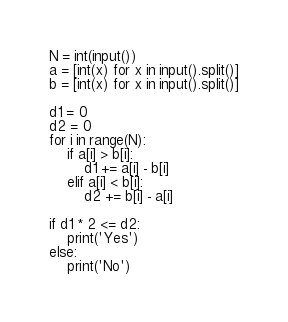Convert code to text. <code><loc_0><loc_0><loc_500><loc_500><_Python_>N = int(input())
a = [int(x) for x in input().split()]
b = [int(x) for x in input().split()]

d1 = 0
d2 = 0
for i in range(N):
    if a[i] > b[i]:
        d1 += a[i] - b[i]
    elif a[i] < b[i]:
        d2 += b[i] - a[i]

if d1 * 2 <= d2:
    print('Yes')
else:
    print('No')</code> 